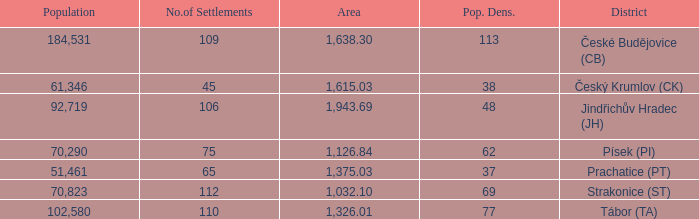How big is the area that has a population density of 113 and a population larger than 184,531? 0.0. 